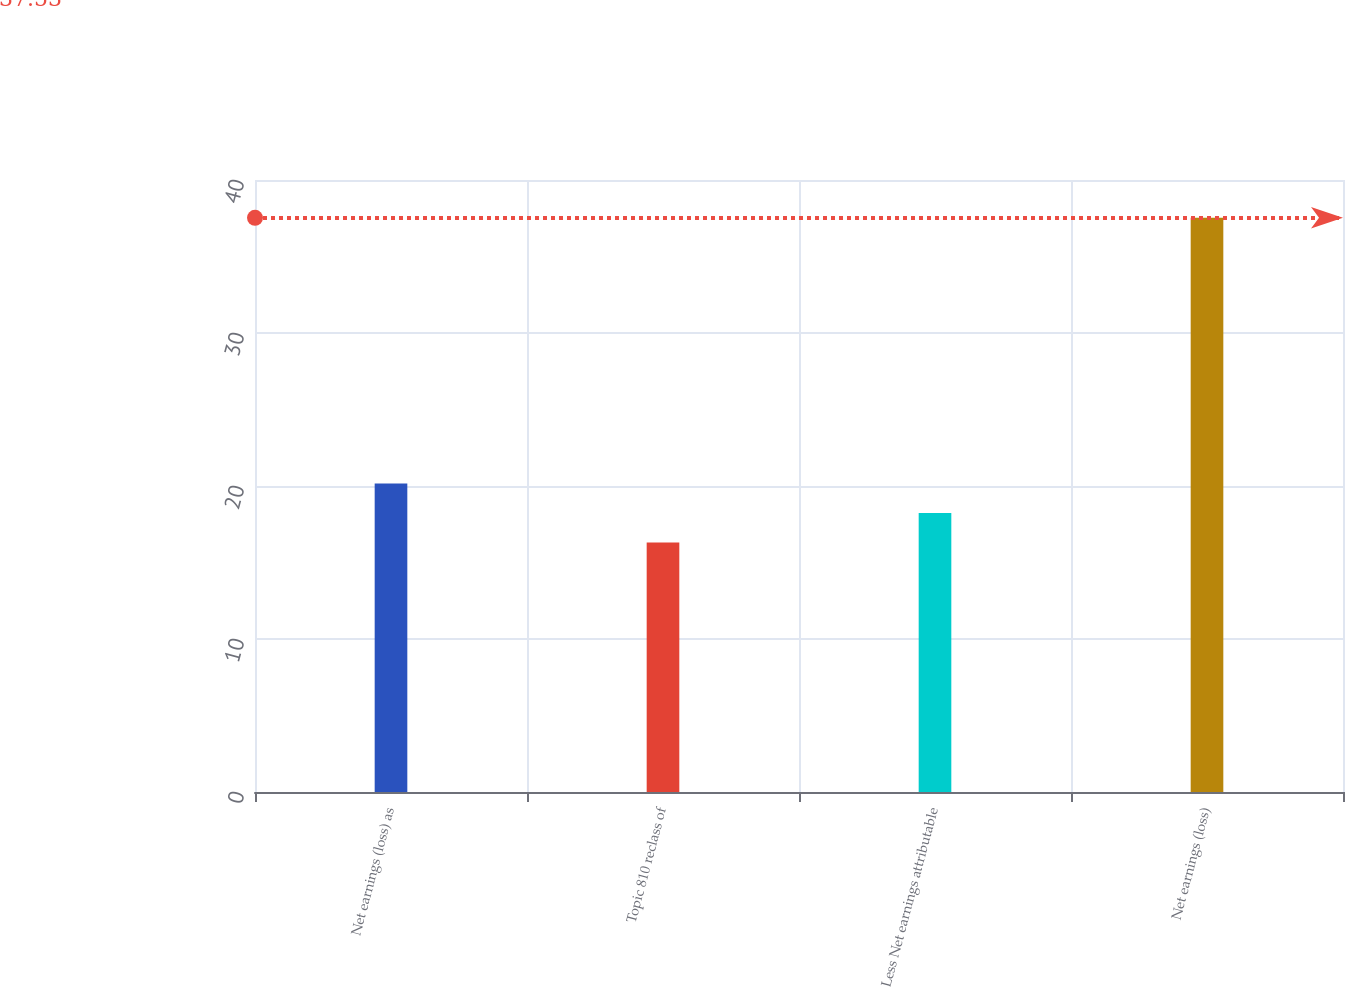<chart> <loc_0><loc_0><loc_500><loc_500><bar_chart><fcel>Net earnings (loss) as<fcel>Topic 810 reclass of<fcel>Less Net earnings attributable<fcel>Net earnings (loss)<nl><fcel>20.16<fcel>16.3<fcel>18.23<fcel>37.53<nl></chart> 